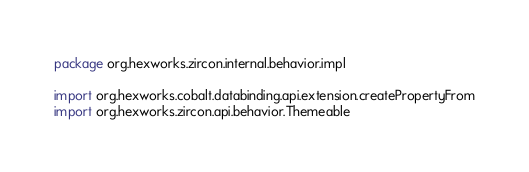Convert code to text. <code><loc_0><loc_0><loc_500><loc_500><_Kotlin_>package org.hexworks.zircon.internal.behavior.impl

import org.hexworks.cobalt.databinding.api.extension.createPropertyFrom
import org.hexworks.zircon.api.behavior.Themeable</code> 